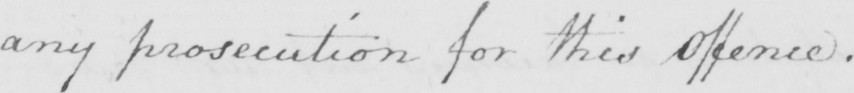Please provide the text content of this handwritten line. any prosecution for this offence . 